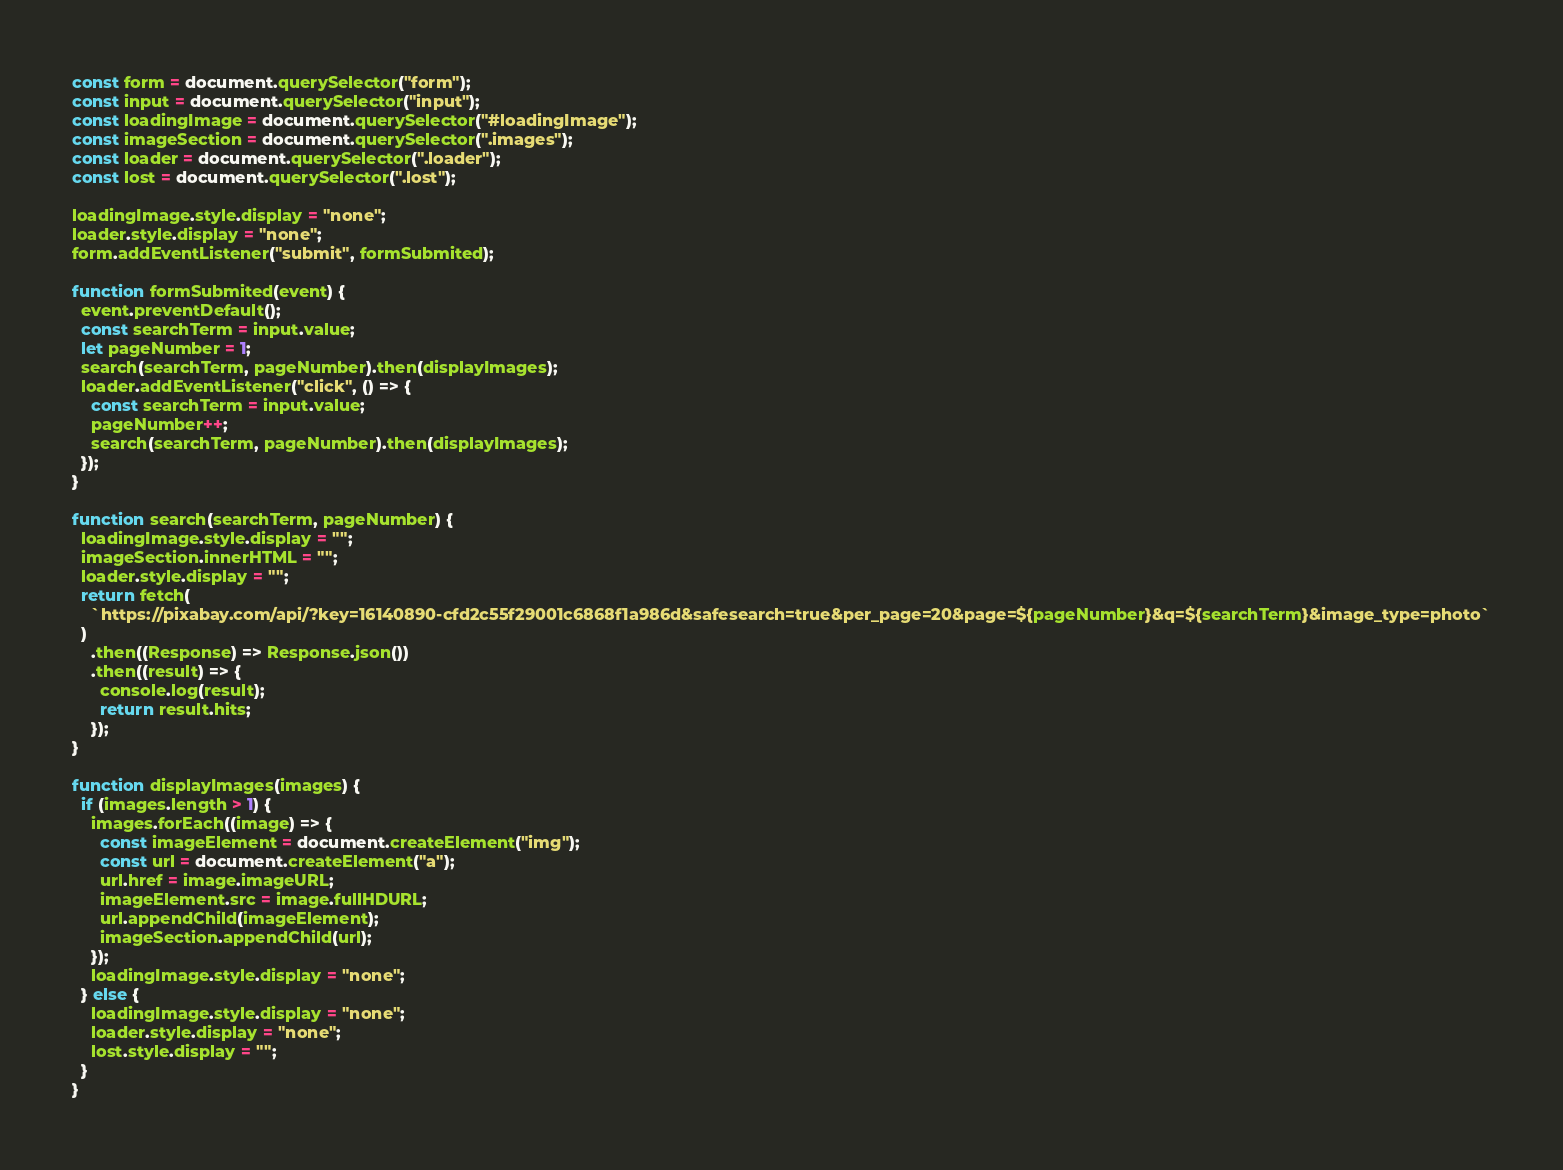Convert code to text. <code><loc_0><loc_0><loc_500><loc_500><_JavaScript_>const form = document.querySelector("form");
const input = document.querySelector("input");
const loadingImage = document.querySelector("#loadingImage");
const imageSection = document.querySelector(".images");
const loader = document.querySelector(".loader");
const lost = document.querySelector(".lost");

loadingImage.style.display = "none";
loader.style.display = "none";
form.addEventListener("submit", formSubmited);

function formSubmited(event) {
  event.preventDefault();
  const searchTerm = input.value;
  let pageNumber = 1;
  search(searchTerm, pageNumber).then(displayImages);
  loader.addEventListener("click", () => {
    const searchTerm = input.value;
    pageNumber++;
    search(searchTerm, pageNumber).then(displayImages);
  });
}

function search(searchTerm, pageNumber) {
  loadingImage.style.display = "";
  imageSection.innerHTML = "";
  loader.style.display = "";
  return fetch(
    `https://pixabay.com/api/?key=16140890-cfd2c55f29001c6868f1a986d&safesearch=true&per_page=20&page=${pageNumber}&q=${searchTerm}&image_type=photo`
  )
    .then((Response) => Response.json())
    .then((result) => {
      console.log(result);
      return result.hits;
    });
}

function displayImages(images) {
  if (images.length > 1) {
    images.forEach((image) => {
      const imageElement = document.createElement("img");
      const url = document.createElement("a");
      url.href = image.imageURL;
      imageElement.src = image.fullHDURL;
      url.appendChild(imageElement);
      imageSection.appendChild(url);
    });
    loadingImage.style.display = "none";
  } else {
    loadingImage.style.display = "none";
    loader.style.display = "none";
    lost.style.display = "";
  }
}
</code> 